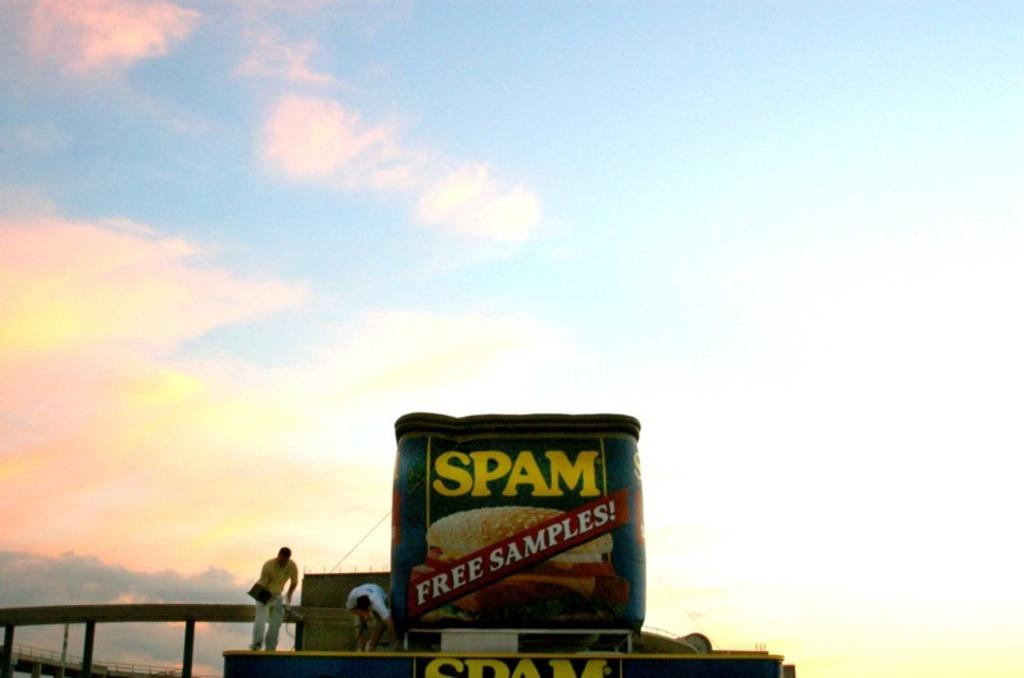Provide a one-sentence caption for the provided image. A large inflatable can of Spam advertises "Free Samples!". 